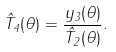<formula> <loc_0><loc_0><loc_500><loc_500>\hat { T } _ { 4 } ( \theta ) = \frac { y _ { 3 } ( \theta ) } { \hat { T } _ { 2 } ( \theta ) } .</formula> 